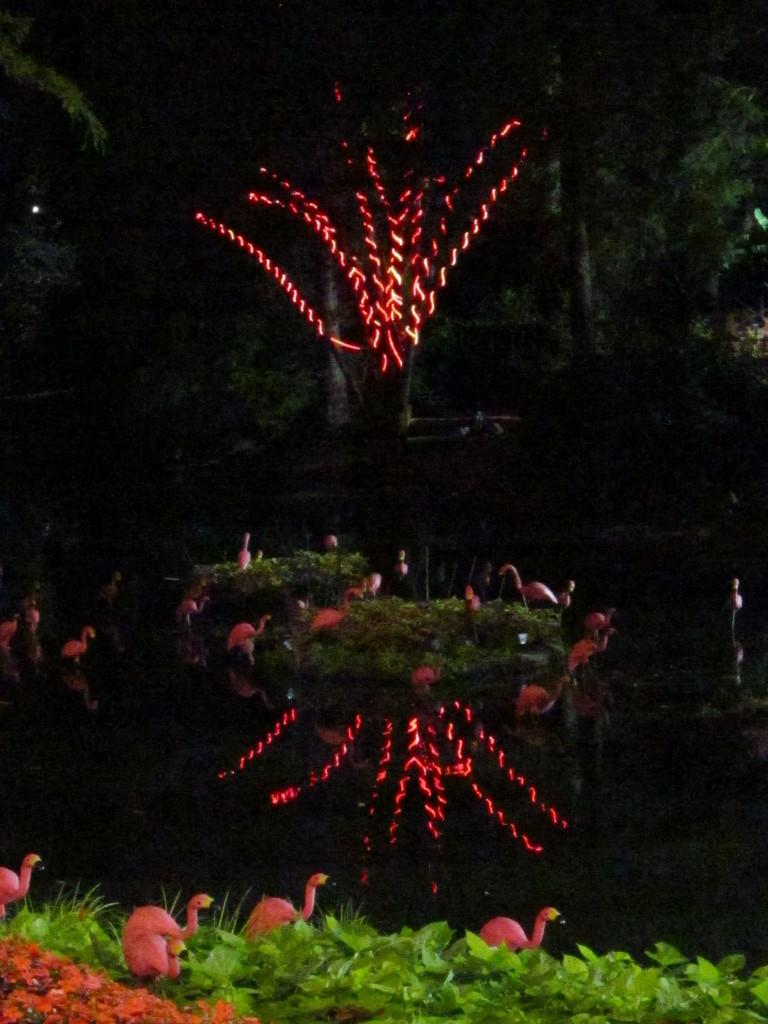What type of vegetation is at the bottom of the image? There is grass at the bottom of the image. What animals can be seen in the image? There are birds in the image. What structure is in the middle of the image? There is a tree in the middle of the image. What type of illumination is present in the image? There are lights in the image. What type of pin can be seen holding the banana in the image? There is no pin or banana present in the image. How does the winter affect the birds in the image? There is no mention of winter in the image, and therefore its effect on the birds cannot be determined. 